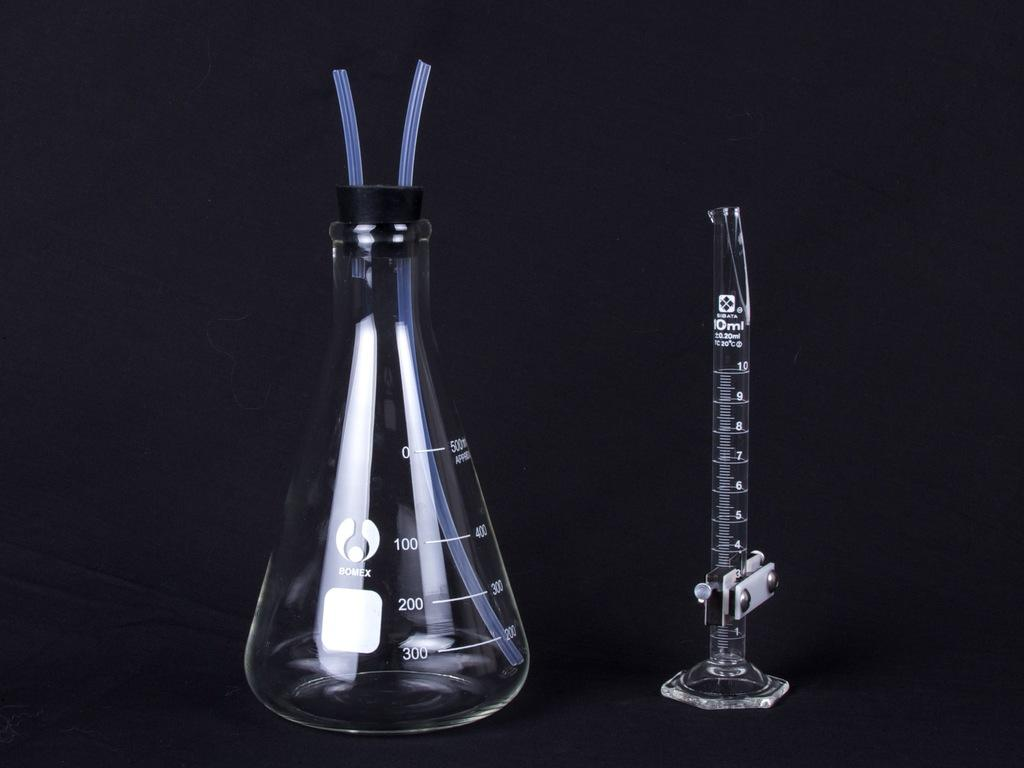<image>
Present a compact description of the photo's key features. Fat beakers next to a skinny beaker which says 10 Ml on it. 